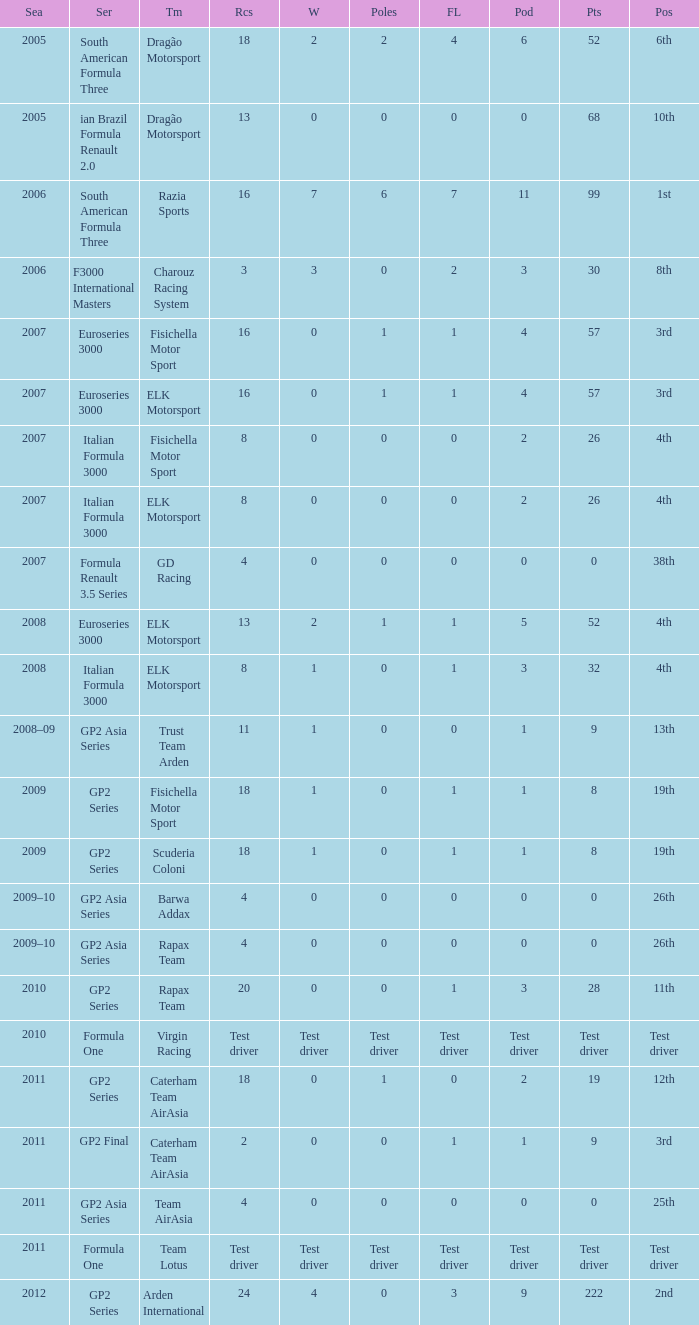What was his position in 2009 with 1 win? 19th, 19th. 